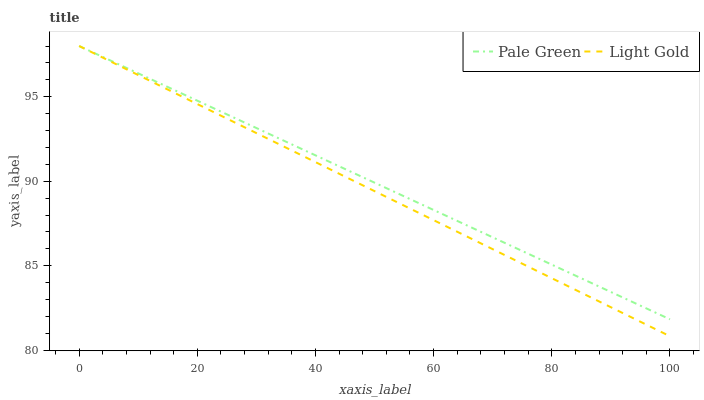Does Light Gold have the minimum area under the curve?
Answer yes or no. Yes. Does Pale Green have the maximum area under the curve?
Answer yes or no. Yes. Does Light Gold have the maximum area under the curve?
Answer yes or no. No. Is Pale Green the smoothest?
Answer yes or no. Yes. Is Light Gold the roughest?
Answer yes or no. Yes. Is Light Gold the smoothest?
Answer yes or no. No. Does Light Gold have the lowest value?
Answer yes or no. Yes. Does Light Gold have the highest value?
Answer yes or no. Yes. Does Pale Green intersect Light Gold?
Answer yes or no. Yes. Is Pale Green less than Light Gold?
Answer yes or no. No. Is Pale Green greater than Light Gold?
Answer yes or no. No. 